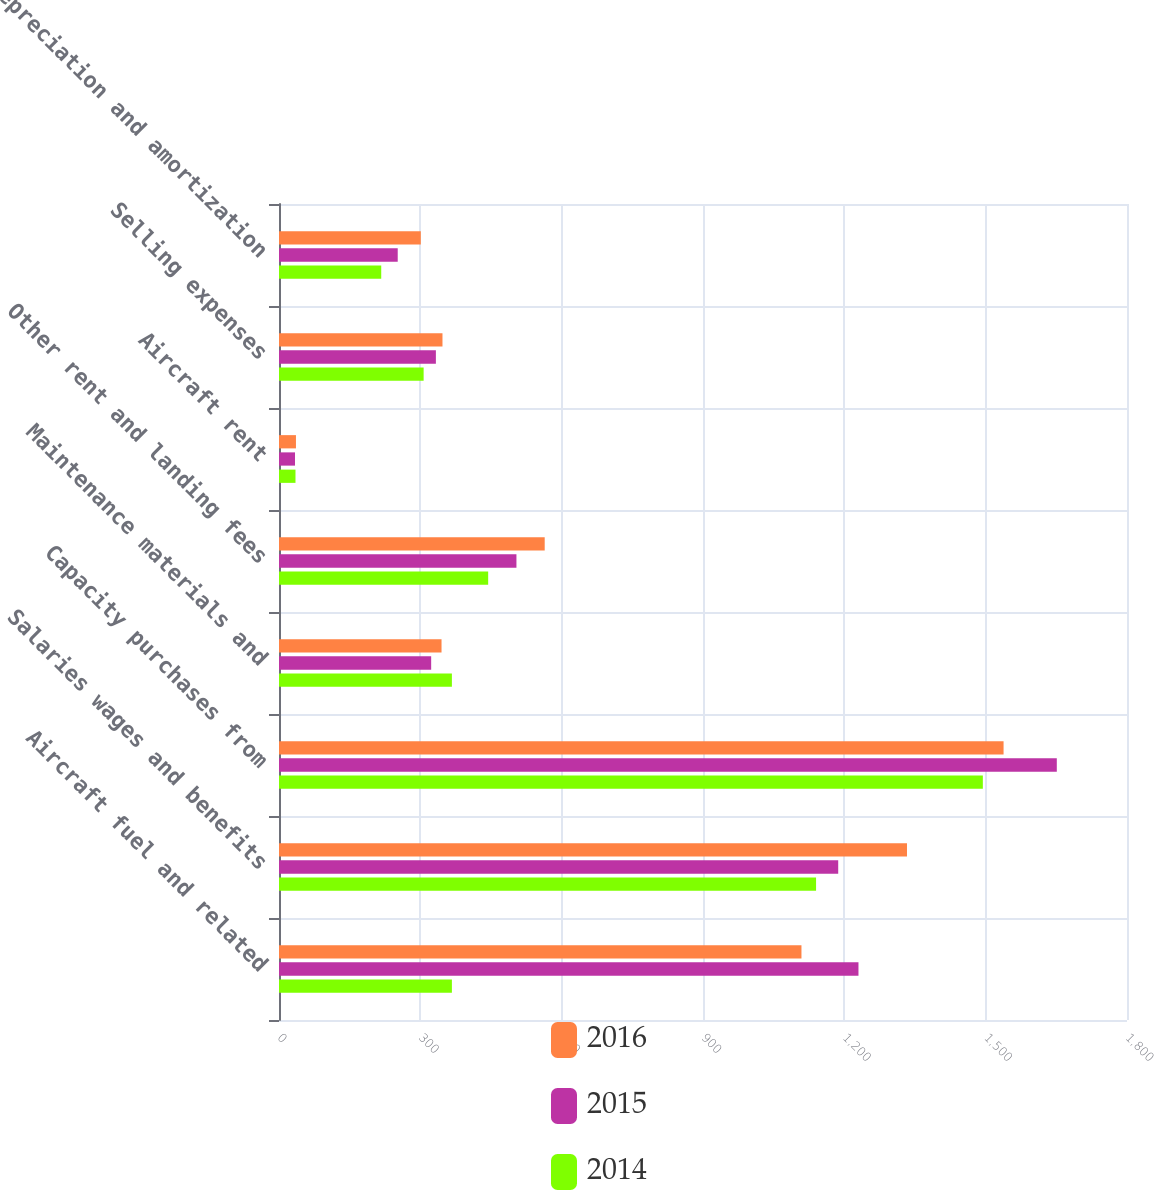Convert chart to OTSL. <chart><loc_0><loc_0><loc_500><loc_500><stacked_bar_chart><ecel><fcel>Aircraft fuel and related<fcel>Salaries wages and benefits<fcel>Capacity purchases from<fcel>Maintenance materials and<fcel>Other rent and landing fees<fcel>Aircraft rent<fcel>Selling expenses<fcel>Depreciation and amortization<nl><fcel>2016<fcel>1109<fcel>1333<fcel>1538<fcel>345<fcel>564<fcel>36<fcel>347<fcel>301<nl><fcel>2015<fcel>1230<fcel>1187<fcel>1651<fcel>323<fcel>504<fcel>34<fcel>333<fcel>252<nl><fcel>2014<fcel>367<fcel>1140<fcel>1494<fcel>367<fcel>444<fcel>35<fcel>307<fcel>217<nl></chart> 